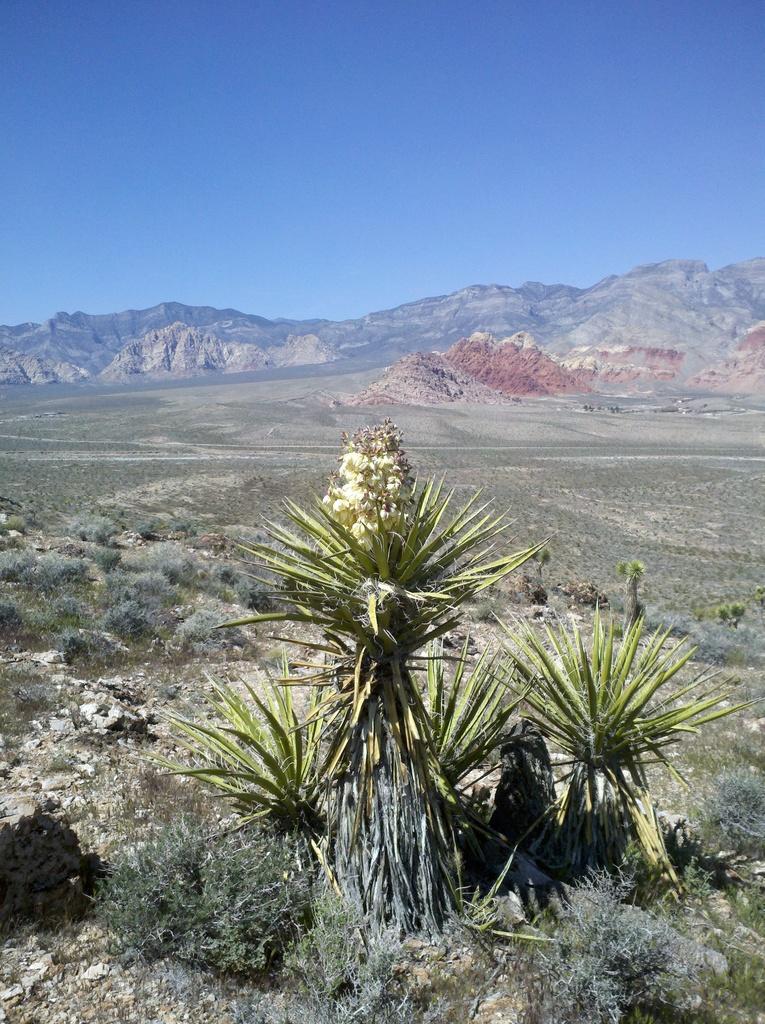Please provide a concise description of this image. This is the picture of a mountain. In the foreground there are plants. At the back there are mountains. At the top there is sky. 